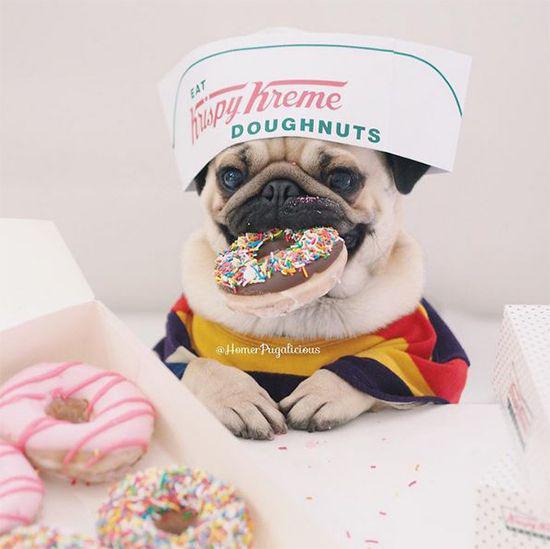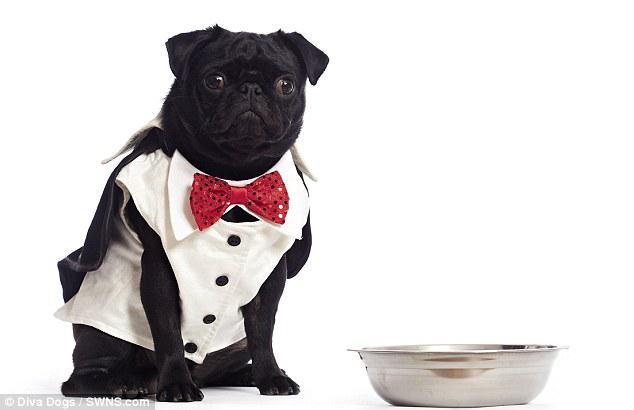The first image is the image on the left, the second image is the image on the right. Considering the images on both sides, is "A dog has a white dish in front of him." valid? Answer yes or no. No. The first image is the image on the left, the second image is the image on the right. Examine the images to the left and right. Is the description "The left image shows a pug with something edible in front of him, and the right image shows a pug in a collared shirt with a bowl in front of him." accurate? Answer yes or no. Yes. 